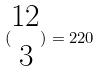<formula> <loc_0><loc_0><loc_500><loc_500>( \begin{matrix} 1 2 \\ 3 \end{matrix} ) = 2 2 0</formula> 